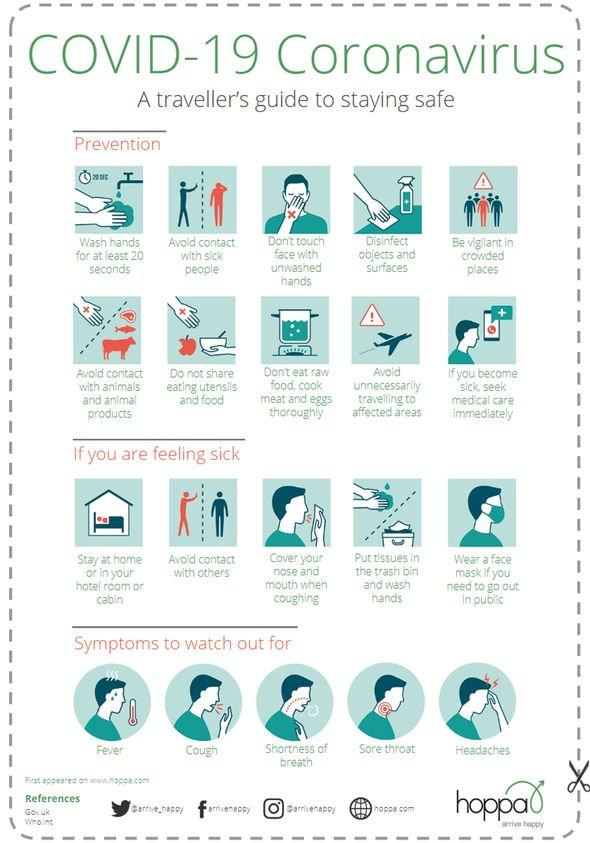Mention a couple of crucial points in this snapshot. The image displays a total of five symptoms. To prevent the Coronavirus infection, the second tip is to avoid contact with sick individuals. The ninth tip for the prevention of COVID-19 infection recommended by experts is to avoid traveling to areas that have been affected by the virus unless it is absolutely necessary. Ten tips are mentioned for the prevention of coronavirus. The third symptom mentioned is shortness of breath. 